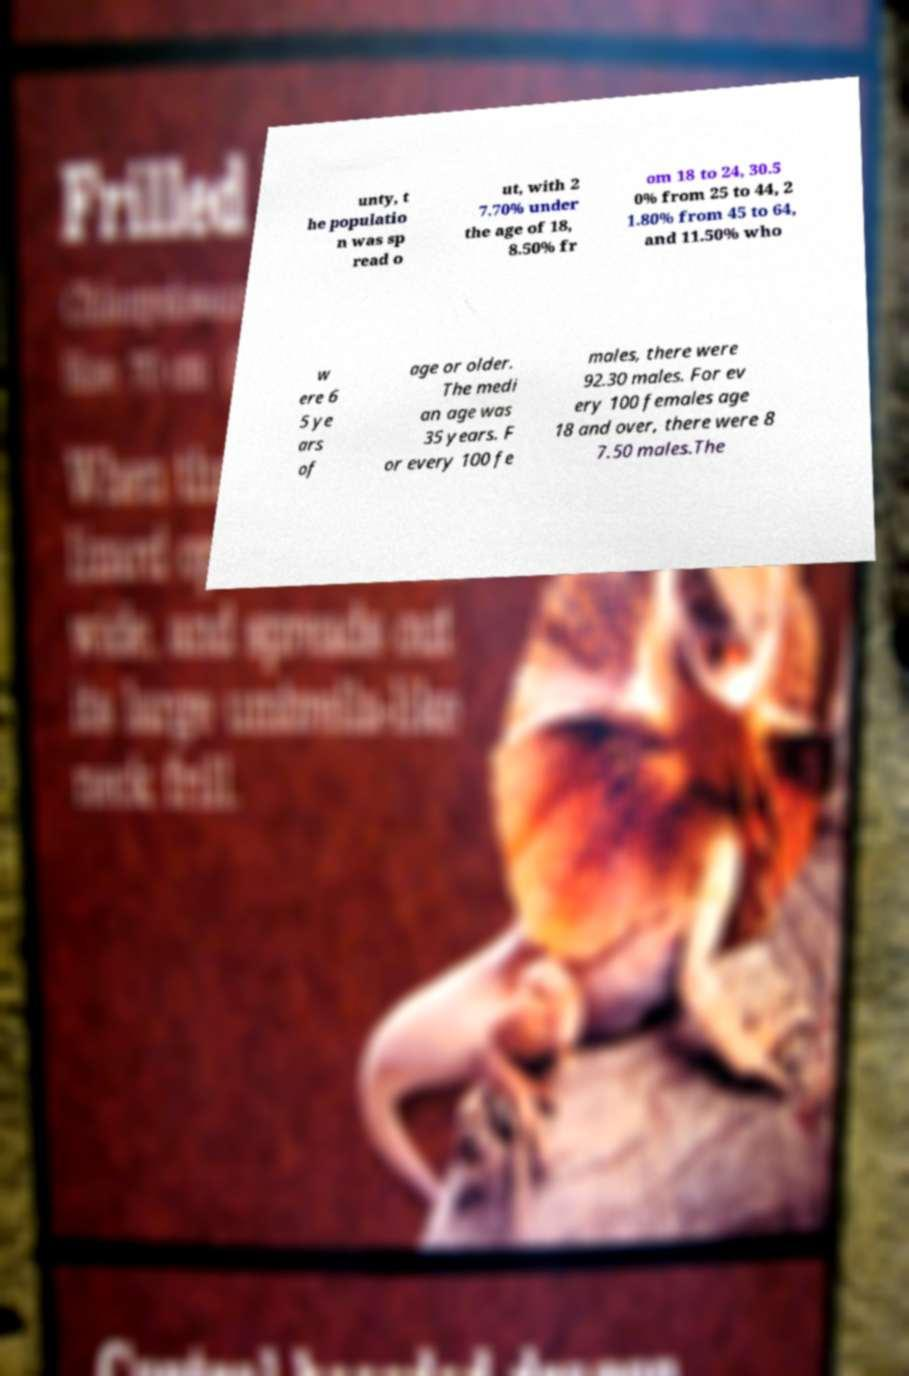Please identify and transcribe the text found in this image. unty, t he populatio n was sp read o ut, with 2 7.70% under the age of 18, 8.50% fr om 18 to 24, 30.5 0% from 25 to 44, 2 1.80% from 45 to 64, and 11.50% who w ere 6 5 ye ars of age or older. The medi an age was 35 years. F or every 100 fe males, there were 92.30 males. For ev ery 100 females age 18 and over, there were 8 7.50 males.The 